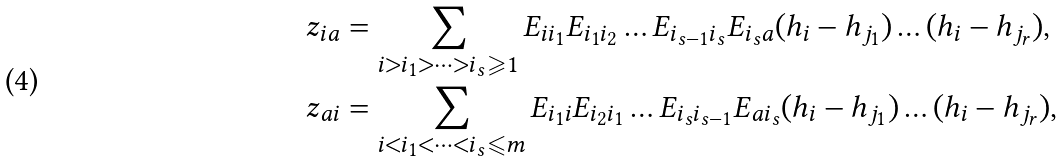Convert formula to latex. <formula><loc_0><loc_0><loc_500><loc_500>z _ { i a } & = \sum _ { i > i _ { 1 } > \dots > i _ { s } \geqslant 1 } E _ { i i _ { 1 } } E _ { i _ { 1 } i _ { 2 } } \dots E _ { i _ { s - 1 } i _ { s } } E _ { i _ { s } a } ( h _ { i } - h _ { j _ { 1 } } ) \dots ( h _ { i } - h _ { j _ { r } } ) , \\ z _ { a i } & = \sum _ { i < i _ { 1 } < \dots < i _ { s } \leqslant m } E _ { i _ { 1 } i } E _ { i _ { 2 } i _ { 1 } } \dots E _ { i _ { s } i _ { s - 1 } } E _ { a i _ { s } } ( h _ { i } - h _ { j _ { 1 } } ) \dots ( h _ { i } - h _ { j _ { r } } ) ,</formula> 